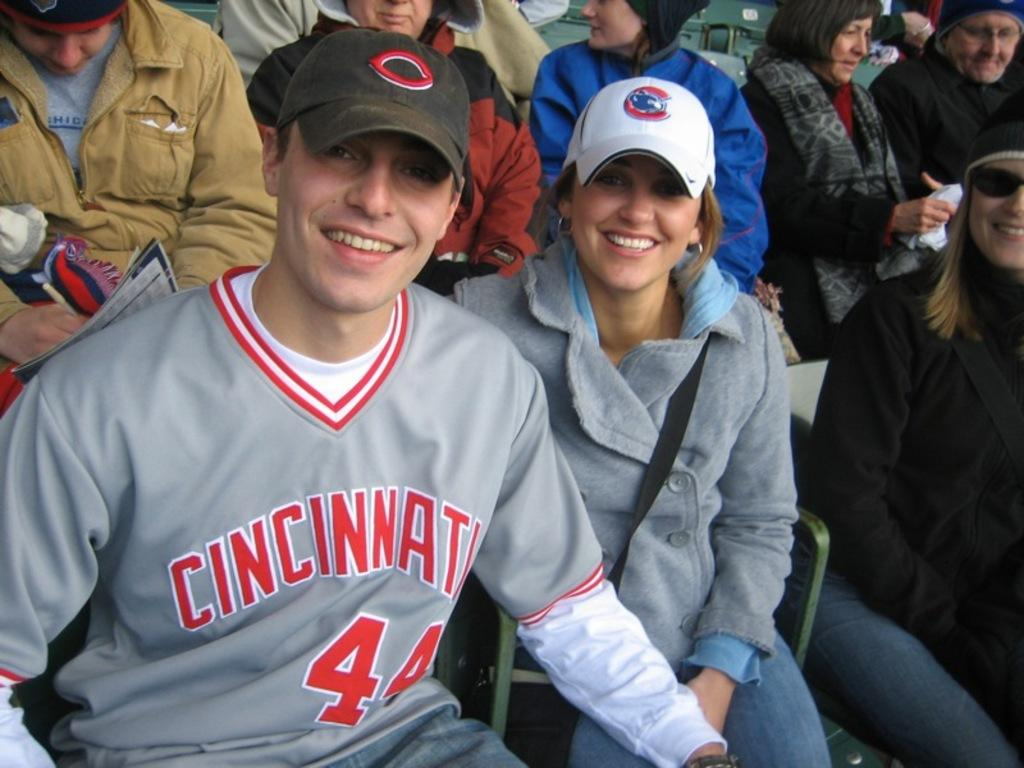<image>
Summarize the visual content of the image. Two people smiling at a sports game in Cincinnati. 